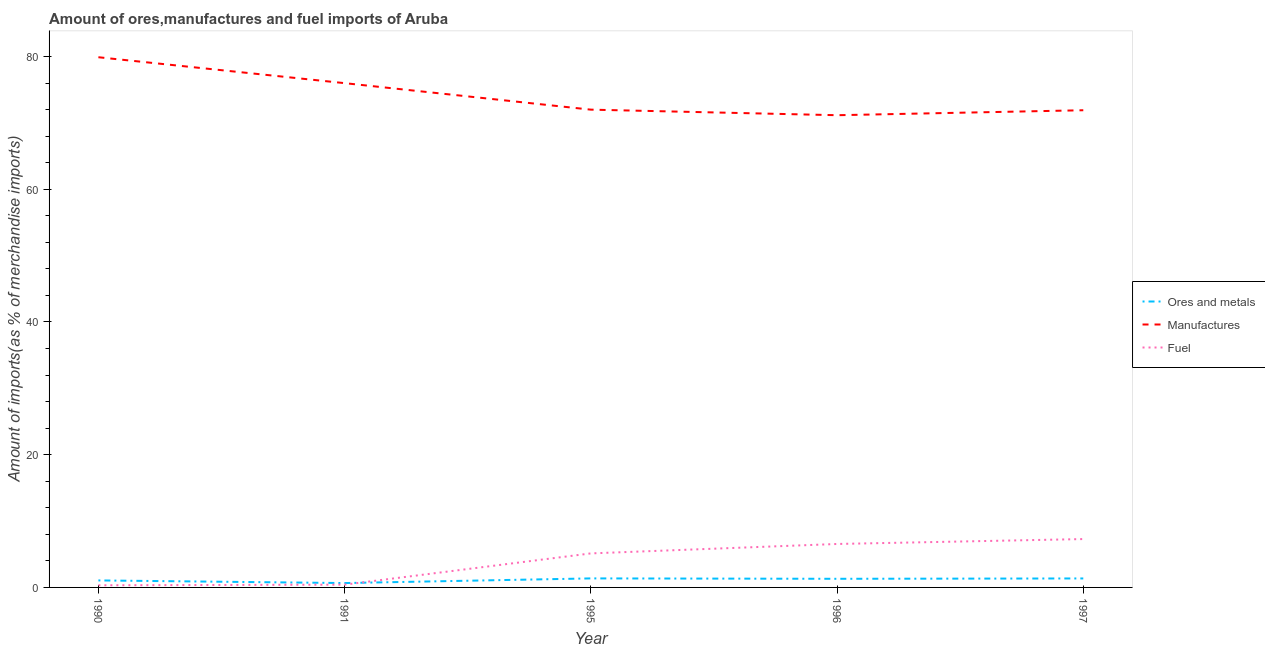How many different coloured lines are there?
Offer a very short reply. 3. Does the line corresponding to percentage of manufactures imports intersect with the line corresponding to percentage of fuel imports?
Your answer should be very brief. No. What is the percentage of ores and metals imports in 1996?
Provide a short and direct response. 1.3. Across all years, what is the maximum percentage of ores and metals imports?
Keep it short and to the point. 1.36. Across all years, what is the minimum percentage of ores and metals imports?
Your answer should be compact. 0.66. What is the total percentage of manufactures imports in the graph?
Provide a short and direct response. 370.91. What is the difference between the percentage of manufactures imports in 1996 and that in 1997?
Provide a short and direct response. -0.75. What is the difference between the percentage of manufactures imports in 1997 and the percentage of fuel imports in 1991?
Ensure brevity in your answer.  71.48. What is the average percentage of manufactures imports per year?
Ensure brevity in your answer.  74.18. In the year 1991, what is the difference between the percentage of fuel imports and percentage of manufactures imports?
Provide a succinct answer. -75.56. In how many years, is the percentage of manufactures imports greater than 20 %?
Keep it short and to the point. 5. What is the ratio of the percentage of fuel imports in 1991 to that in 1995?
Provide a short and direct response. 0.08. Is the percentage of fuel imports in 1996 less than that in 1997?
Offer a terse response. Yes. What is the difference between the highest and the second highest percentage of fuel imports?
Offer a very short reply. 0.74. What is the difference between the highest and the lowest percentage of fuel imports?
Provide a short and direct response. 6.97. In how many years, is the percentage of fuel imports greater than the average percentage of fuel imports taken over all years?
Offer a very short reply. 3. Is the sum of the percentage of manufactures imports in 1995 and 1996 greater than the maximum percentage of fuel imports across all years?
Provide a succinct answer. Yes. Does the percentage of ores and metals imports monotonically increase over the years?
Provide a succinct answer. No. Are the values on the major ticks of Y-axis written in scientific E-notation?
Give a very brief answer. No. Does the graph contain any zero values?
Offer a very short reply. No. Does the graph contain grids?
Your answer should be compact. No. How many legend labels are there?
Keep it short and to the point. 3. How are the legend labels stacked?
Your answer should be compact. Vertical. What is the title of the graph?
Your answer should be very brief. Amount of ores,manufactures and fuel imports of Aruba. What is the label or title of the Y-axis?
Give a very brief answer. Amount of imports(as % of merchandise imports). What is the Amount of imports(as % of merchandise imports) in Ores and metals in 1990?
Give a very brief answer. 1.06. What is the Amount of imports(as % of merchandise imports) of Manufactures in 1990?
Your answer should be very brief. 79.89. What is the Amount of imports(as % of merchandise imports) in Fuel in 1990?
Offer a terse response. 0.32. What is the Amount of imports(as % of merchandise imports) in Ores and metals in 1991?
Your response must be concise. 0.66. What is the Amount of imports(as % of merchandise imports) in Manufactures in 1991?
Your answer should be very brief. 75.98. What is the Amount of imports(as % of merchandise imports) in Fuel in 1991?
Keep it short and to the point. 0.42. What is the Amount of imports(as % of merchandise imports) of Ores and metals in 1995?
Ensure brevity in your answer.  1.36. What is the Amount of imports(as % of merchandise imports) in Manufactures in 1995?
Give a very brief answer. 71.99. What is the Amount of imports(as % of merchandise imports) in Fuel in 1995?
Your answer should be very brief. 5.13. What is the Amount of imports(as % of merchandise imports) in Ores and metals in 1996?
Offer a terse response. 1.3. What is the Amount of imports(as % of merchandise imports) of Manufactures in 1996?
Offer a very short reply. 71.15. What is the Amount of imports(as % of merchandise imports) of Fuel in 1996?
Your answer should be compact. 6.55. What is the Amount of imports(as % of merchandise imports) of Ores and metals in 1997?
Your answer should be compact. 1.35. What is the Amount of imports(as % of merchandise imports) in Manufactures in 1997?
Provide a short and direct response. 71.9. What is the Amount of imports(as % of merchandise imports) in Fuel in 1997?
Your answer should be compact. 7.29. Across all years, what is the maximum Amount of imports(as % of merchandise imports) in Ores and metals?
Make the answer very short. 1.36. Across all years, what is the maximum Amount of imports(as % of merchandise imports) of Manufactures?
Provide a short and direct response. 79.89. Across all years, what is the maximum Amount of imports(as % of merchandise imports) in Fuel?
Provide a succinct answer. 7.29. Across all years, what is the minimum Amount of imports(as % of merchandise imports) in Ores and metals?
Provide a succinct answer. 0.66. Across all years, what is the minimum Amount of imports(as % of merchandise imports) in Manufactures?
Your answer should be compact. 71.15. Across all years, what is the minimum Amount of imports(as % of merchandise imports) of Fuel?
Keep it short and to the point. 0.32. What is the total Amount of imports(as % of merchandise imports) of Ores and metals in the graph?
Give a very brief answer. 5.73. What is the total Amount of imports(as % of merchandise imports) in Manufactures in the graph?
Ensure brevity in your answer.  370.91. What is the total Amount of imports(as % of merchandise imports) of Fuel in the graph?
Offer a terse response. 19.7. What is the difference between the Amount of imports(as % of merchandise imports) of Ores and metals in 1990 and that in 1991?
Provide a short and direct response. 0.4. What is the difference between the Amount of imports(as % of merchandise imports) of Manufactures in 1990 and that in 1991?
Make the answer very short. 3.9. What is the difference between the Amount of imports(as % of merchandise imports) of Fuel in 1990 and that in 1991?
Offer a terse response. -0.1. What is the difference between the Amount of imports(as % of merchandise imports) in Ores and metals in 1990 and that in 1995?
Provide a succinct answer. -0.3. What is the difference between the Amount of imports(as % of merchandise imports) of Manufactures in 1990 and that in 1995?
Ensure brevity in your answer.  7.9. What is the difference between the Amount of imports(as % of merchandise imports) of Fuel in 1990 and that in 1995?
Your answer should be compact. -4.81. What is the difference between the Amount of imports(as % of merchandise imports) in Ores and metals in 1990 and that in 1996?
Your answer should be very brief. -0.24. What is the difference between the Amount of imports(as % of merchandise imports) of Manufactures in 1990 and that in 1996?
Provide a short and direct response. 8.74. What is the difference between the Amount of imports(as % of merchandise imports) of Fuel in 1990 and that in 1996?
Make the answer very short. -6.23. What is the difference between the Amount of imports(as % of merchandise imports) in Ores and metals in 1990 and that in 1997?
Give a very brief answer. -0.3. What is the difference between the Amount of imports(as % of merchandise imports) of Manufactures in 1990 and that in 1997?
Your answer should be very brief. 7.99. What is the difference between the Amount of imports(as % of merchandise imports) in Fuel in 1990 and that in 1997?
Your response must be concise. -6.97. What is the difference between the Amount of imports(as % of merchandise imports) of Ores and metals in 1991 and that in 1995?
Keep it short and to the point. -0.7. What is the difference between the Amount of imports(as % of merchandise imports) in Manufactures in 1991 and that in 1995?
Provide a succinct answer. 3.99. What is the difference between the Amount of imports(as % of merchandise imports) of Fuel in 1991 and that in 1995?
Make the answer very short. -4.71. What is the difference between the Amount of imports(as % of merchandise imports) in Ores and metals in 1991 and that in 1996?
Provide a short and direct response. -0.64. What is the difference between the Amount of imports(as % of merchandise imports) in Manufactures in 1991 and that in 1996?
Give a very brief answer. 4.83. What is the difference between the Amount of imports(as % of merchandise imports) of Fuel in 1991 and that in 1996?
Provide a succinct answer. -6.13. What is the difference between the Amount of imports(as % of merchandise imports) of Ores and metals in 1991 and that in 1997?
Give a very brief answer. -0.69. What is the difference between the Amount of imports(as % of merchandise imports) of Manufactures in 1991 and that in 1997?
Your answer should be very brief. 4.08. What is the difference between the Amount of imports(as % of merchandise imports) in Fuel in 1991 and that in 1997?
Provide a succinct answer. -6.87. What is the difference between the Amount of imports(as % of merchandise imports) of Ores and metals in 1995 and that in 1996?
Provide a short and direct response. 0.06. What is the difference between the Amount of imports(as % of merchandise imports) of Manufactures in 1995 and that in 1996?
Provide a short and direct response. 0.84. What is the difference between the Amount of imports(as % of merchandise imports) of Fuel in 1995 and that in 1996?
Your answer should be compact. -1.42. What is the difference between the Amount of imports(as % of merchandise imports) in Ores and metals in 1995 and that in 1997?
Give a very brief answer. 0.01. What is the difference between the Amount of imports(as % of merchandise imports) in Manufactures in 1995 and that in 1997?
Your answer should be compact. 0.09. What is the difference between the Amount of imports(as % of merchandise imports) in Fuel in 1995 and that in 1997?
Offer a terse response. -2.16. What is the difference between the Amount of imports(as % of merchandise imports) in Ores and metals in 1996 and that in 1997?
Make the answer very short. -0.05. What is the difference between the Amount of imports(as % of merchandise imports) of Manufactures in 1996 and that in 1997?
Offer a very short reply. -0.75. What is the difference between the Amount of imports(as % of merchandise imports) in Fuel in 1996 and that in 1997?
Provide a short and direct response. -0.74. What is the difference between the Amount of imports(as % of merchandise imports) of Ores and metals in 1990 and the Amount of imports(as % of merchandise imports) of Manufactures in 1991?
Offer a very short reply. -74.93. What is the difference between the Amount of imports(as % of merchandise imports) of Ores and metals in 1990 and the Amount of imports(as % of merchandise imports) of Fuel in 1991?
Offer a very short reply. 0.64. What is the difference between the Amount of imports(as % of merchandise imports) in Manufactures in 1990 and the Amount of imports(as % of merchandise imports) in Fuel in 1991?
Your answer should be compact. 79.47. What is the difference between the Amount of imports(as % of merchandise imports) of Ores and metals in 1990 and the Amount of imports(as % of merchandise imports) of Manufactures in 1995?
Ensure brevity in your answer.  -70.93. What is the difference between the Amount of imports(as % of merchandise imports) of Ores and metals in 1990 and the Amount of imports(as % of merchandise imports) of Fuel in 1995?
Give a very brief answer. -4.07. What is the difference between the Amount of imports(as % of merchandise imports) in Manufactures in 1990 and the Amount of imports(as % of merchandise imports) in Fuel in 1995?
Make the answer very short. 74.76. What is the difference between the Amount of imports(as % of merchandise imports) of Ores and metals in 1990 and the Amount of imports(as % of merchandise imports) of Manufactures in 1996?
Your answer should be compact. -70.1. What is the difference between the Amount of imports(as % of merchandise imports) in Ores and metals in 1990 and the Amount of imports(as % of merchandise imports) in Fuel in 1996?
Make the answer very short. -5.49. What is the difference between the Amount of imports(as % of merchandise imports) of Manufactures in 1990 and the Amount of imports(as % of merchandise imports) of Fuel in 1996?
Provide a short and direct response. 73.34. What is the difference between the Amount of imports(as % of merchandise imports) in Ores and metals in 1990 and the Amount of imports(as % of merchandise imports) in Manufactures in 1997?
Give a very brief answer. -70.84. What is the difference between the Amount of imports(as % of merchandise imports) of Ores and metals in 1990 and the Amount of imports(as % of merchandise imports) of Fuel in 1997?
Your answer should be very brief. -6.23. What is the difference between the Amount of imports(as % of merchandise imports) in Manufactures in 1990 and the Amount of imports(as % of merchandise imports) in Fuel in 1997?
Ensure brevity in your answer.  72.6. What is the difference between the Amount of imports(as % of merchandise imports) of Ores and metals in 1991 and the Amount of imports(as % of merchandise imports) of Manufactures in 1995?
Ensure brevity in your answer.  -71.33. What is the difference between the Amount of imports(as % of merchandise imports) of Ores and metals in 1991 and the Amount of imports(as % of merchandise imports) of Fuel in 1995?
Your answer should be very brief. -4.47. What is the difference between the Amount of imports(as % of merchandise imports) of Manufactures in 1991 and the Amount of imports(as % of merchandise imports) of Fuel in 1995?
Ensure brevity in your answer.  70.86. What is the difference between the Amount of imports(as % of merchandise imports) of Ores and metals in 1991 and the Amount of imports(as % of merchandise imports) of Manufactures in 1996?
Your answer should be very brief. -70.49. What is the difference between the Amount of imports(as % of merchandise imports) in Ores and metals in 1991 and the Amount of imports(as % of merchandise imports) in Fuel in 1996?
Offer a very short reply. -5.89. What is the difference between the Amount of imports(as % of merchandise imports) in Manufactures in 1991 and the Amount of imports(as % of merchandise imports) in Fuel in 1996?
Your response must be concise. 69.44. What is the difference between the Amount of imports(as % of merchandise imports) in Ores and metals in 1991 and the Amount of imports(as % of merchandise imports) in Manufactures in 1997?
Your response must be concise. -71.24. What is the difference between the Amount of imports(as % of merchandise imports) of Ores and metals in 1991 and the Amount of imports(as % of merchandise imports) of Fuel in 1997?
Give a very brief answer. -6.63. What is the difference between the Amount of imports(as % of merchandise imports) of Manufactures in 1991 and the Amount of imports(as % of merchandise imports) of Fuel in 1997?
Your answer should be very brief. 68.69. What is the difference between the Amount of imports(as % of merchandise imports) in Ores and metals in 1995 and the Amount of imports(as % of merchandise imports) in Manufactures in 1996?
Ensure brevity in your answer.  -69.79. What is the difference between the Amount of imports(as % of merchandise imports) of Ores and metals in 1995 and the Amount of imports(as % of merchandise imports) of Fuel in 1996?
Give a very brief answer. -5.19. What is the difference between the Amount of imports(as % of merchandise imports) of Manufactures in 1995 and the Amount of imports(as % of merchandise imports) of Fuel in 1996?
Your answer should be compact. 65.44. What is the difference between the Amount of imports(as % of merchandise imports) in Ores and metals in 1995 and the Amount of imports(as % of merchandise imports) in Manufactures in 1997?
Provide a short and direct response. -70.54. What is the difference between the Amount of imports(as % of merchandise imports) in Ores and metals in 1995 and the Amount of imports(as % of merchandise imports) in Fuel in 1997?
Provide a short and direct response. -5.93. What is the difference between the Amount of imports(as % of merchandise imports) in Manufactures in 1995 and the Amount of imports(as % of merchandise imports) in Fuel in 1997?
Keep it short and to the point. 64.7. What is the difference between the Amount of imports(as % of merchandise imports) in Ores and metals in 1996 and the Amount of imports(as % of merchandise imports) in Manufactures in 1997?
Offer a very short reply. -70.6. What is the difference between the Amount of imports(as % of merchandise imports) in Ores and metals in 1996 and the Amount of imports(as % of merchandise imports) in Fuel in 1997?
Offer a very short reply. -5.99. What is the difference between the Amount of imports(as % of merchandise imports) in Manufactures in 1996 and the Amount of imports(as % of merchandise imports) in Fuel in 1997?
Your answer should be very brief. 63.86. What is the average Amount of imports(as % of merchandise imports) in Ores and metals per year?
Your answer should be very brief. 1.15. What is the average Amount of imports(as % of merchandise imports) in Manufactures per year?
Ensure brevity in your answer.  74.18. What is the average Amount of imports(as % of merchandise imports) in Fuel per year?
Provide a succinct answer. 3.94. In the year 1990, what is the difference between the Amount of imports(as % of merchandise imports) in Ores and metals and Amount of imports(as % of merchandise imports) in Manufactures?
Your response must be concise. -78.83. In the year 1990, what is the difference between the Amount of imports(as % of merchandise imports) in Ores and metals and Amount of imports(as % of merchandise imports) in Fuel?
Your answer should be compact. 0.73. In the year 1990, what is the difference between the Amount of imports(as % of merchandise imports) in Manufactures and Amount of imports(as % of merchandise imports) in Fuel?
Provide a succinct answer. 79.57. In the year 1991, what is the difference between the Amount of imports(as % of merchandise imports) of Ores and metals and Amount of imports(as % of merchandise imports) of Manufactures?
Give a very brief answer. -75.32. In the year 1991, what is the difference between the Amount of imports(as % of merchandise imports) in Ores and metals and Amount of imports(as % of merchandise imports) in Fuel?
Make the answer very short. 0.24. In the year 1991, what is the difference between the Amount of imports(as % of merchandise imports) of Manufactures and Amount of imports(as % of merchandise imports) of Fuel?
Ensure brevity in your answer.  75.56. In the year 1995, what is the difference between the Amount of imports(as % of merchandise imports) of Ores and metals and Amount of imports(as % of merchandise imports) of Manufactures?
Give a very brief answer. -70.63. In the year 1995, what is the difference between the Amount of imports(as % of merchandise imports) of Ores and metals and Amount of imports(as % of merchandise imports) of Fuel?
Keep it short and to the point. -3.77. In the year 1995, what is the difference between the Amount of imports(as % of merchandise imports) in Manufactures and Amount of imports(as % of merchandise imports) in Fuel?
Ensure brevity in your answer.  66.86. In the year 1996, what is the difference between the Amount of imports(as % of merchandise imports) in Ores and metals and Amount of imports(as % of merchandise imports) in Manufactures?
Keep it short and to the point. -69.85. In the year 1996, what is the difference between the Amount of imports(as % of merchandise imports) of Ores and metals and Amount of imports(as % of merchandise imports) of Fuel?
Offer a very short reply. -5.25. In the year 1996, what is the difference between the Amount of imports(as % of merchandise imports) in Manufactures and Amount of imports(as % of merchandise imports) in Fuel?
Your response must be concise. 64.6. In the year 1997, what is the difference between the Amount of imports(as % of merchandise imports) of Ores and metals and Amount of imports(as % of merchandise imports) of Manufactures?
Your response must be concise. -70.55. In the year 1997, what is the difference between the Amount of imports(as % of merchandise imports) in Ores and metals and Amount of imports(as % of merchandise imports) in Fuel?
Keep it short and to the point. -5.94. In the year 1997, what is the difference between the Amount of imports(as % of merchandise imports) in Manufactures and Amount of imports(as % of merchandise imports) in Fuel?
Your answer should be compact. 64.61. What is the ratio of the Amount of imports(as % of merchandise imports) of Ores and metals in 1990 to that in 1991?
Offer a very short reply. 1.6. What is the ratio of the Amount of imports(as % of merchandise imports) of Manufactures in 1990 to that in 1991?
Keep it short and to the point. 1.05. What is the ratio of the Amount of imports(as % of merchandise imports) of Fuel in 1990 to that in 1991?
Offer a terse response. 0.77. What is the ratio of the Amount of imports(as % of merchandise imports) of Ores and metals in 1990 to that in 1995?
Your answer should be compact. 0.78. What is the ratio of the Amount of imports(as % of merchandise imports) of Manufactures in 1990 to that in 1995?
Offer a terse response. 1.11. What is the ratio of the Amount of imports(as % of merchandise imports) in Fuel in 1990 to that in 1995?
Your answer should be very brief. 0.06. What is the ratio of the Amount of imports(as % of merchandise imports) in Ores and metals in 1990 to that in 1996?
Your response must be concise. 0.81. What is the ratio of the Amount of imports(as % of merchandise imports) in Manufactures in 1990 to that in 1996?
Offer a very short reply. 1.12. What is the ratio of the Amount of imports(as % of merchandise imports) of Fuel in 1990 to that in 1996?
Give a very brief answer. 0.05. What is the ratio of the Amount of imports(as % of merchandise imports) of Ores and metals in 1990 to that in 1997?
Provide a short and direct response. 0.78. What is the ratio of the Amount of imports(as % of merchandise imports) of Fuel in 1990 to that in 1997?
Give a very brief answer. 0.04. What is the ratio of the Amount of imports(as % of merchandise imports) of Ores and metals in 1991 to that in 1995?
Ensure brevity in your answer.  0.48. What is the ratio of the Amount of imports(as % of merchandise imports) in Manufactures in 1991 to that in 1995?
Your answer should be compact. 1.06. What is the ratio of the Amount of imports(as % of merchandise imports) in Fuel in 1991 to that in 1995?
Ensure brevity in your answer.  0.08. What is the ratio of the Amount of imports(as % of merchandise imports) in Ores and metals in 1991 to that in 1996?
Your answer should be compact. 0.51. What is the ratio of the Amount of imports(as % of merchandise imports) in Manufactures in 1991 to that in 1996?
Provide a short and direct response. 1.07. What is the ratio of the Amount of imports(as % of merchandise imports) of Fuel in 1991 to that in 1996?
Your answer should be very brief. 0.06. What is the ratio of the Amount of imports(as % of merchandise imports) of Ores and metals in 1991 to that in 1997?
Make the answer very short. 0.49. What is the ratio of the Amount of imports(as % of merchandise imports) of Manufactures in 1991 to that in 1997?
Give a very brief answer. 1.06. What is the ratio of the Amount of imports(as % of merchandise imports) of Fuel in 1991 to that in 1997?
Your answer should be very brief. 0.06. What is the ratio of the Amount of imports(as % of merchandise imports) of Ores and metals in 1995 to that in 1996?
Your response must be concise. 1.05. What is the ratio of the Amount of imports(as % of merchandise imports) of Manufactures in 1995 to that in 1996?
Ensure brevity in your answer.  1.01. What is the ratio of the Amount of imports(as % of merchandise imports) of Fuel in 1995 to that in 1996?
Ensure brevity in your answer.  0.78. What is the ratio of the Amount of imports(as % of merchandise imports) of Ores and metals in 1995 to that in 1997?
Ensure brevity in your answer.  1.01. What is the ratio of the Amount of imports(as % of merchandise imports) in Manufactures in 1995 to that in 1997?
Provide a succinct answer. 1. What is the ratio of the Amount of imports(as % of merchandise imports) of Fuel in 1995 to that in 1997?
Offer a terse response. 0.7. What is the ratio of the Amount of imports(as % of merchandise imports) of Ores and metals in 1996 to that in 1997?
Your response must be concise. 0.96. What is the ratio of the Amount of imports(as % of merchandise imports) of Manufactures in 1996 to that in 1997?
Your answer should be very brief. 0.99. What is the ratio of the Amount of imports(as % of merchandise imports) in Fuel in 1996 to that in 1997?
Ensure brevity in your answer.  0.9. What is the difference between the highest and the second highest Amount of imports(as % of merchandise imports) in Ores and metals?
Keep it short and to the point. 0.01. What is the difference between the highest and the second highest Amount of imports(as % of merchandise imports) in Manufactures?
Provide a short and direct response. 3.9. What is the difference between the highest and the second highest Amount of imports(as % of merchandise imports) in Fuel?
Your response must be concise. 0.74. What is the difference between the highest and the lowest Amount of imports(as % of merchandise imports) in Ores and metals?
Keep it short and to the point. 0.7. What is the difference between the highest and the lowest Amount of imports(as % of merchandise imports) in Manufactures?
Provide a short and direct response. 8.74. What is the difference between the highest and the lowest Amount of imports(as % of merchandise imports) of Fuel?
Give a very brief answer. 6.97. 